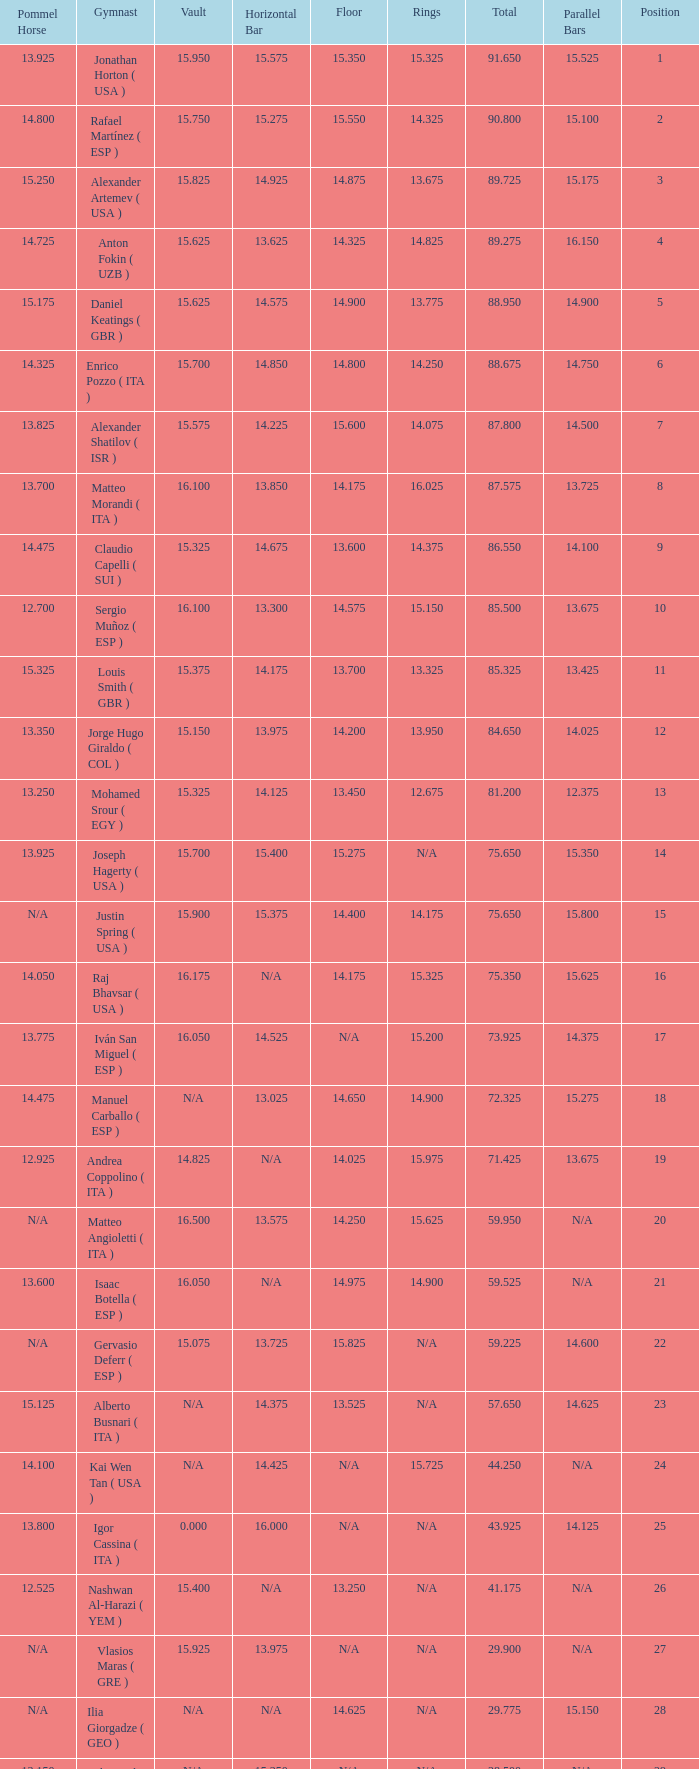Parse the table in full. {'header': ['Pommel Horse', 'Gymnast', 'Vault', 'Horizontal Bar', 'Floor', 'Rings', 'Total', 'Parallel Bars', 'Position'], 'rows': [['13.925', 'Jonathan Horton ( USA )', '15.950', '15.575', '15.350', '15.325', '91.650', '15.525', '1'], ['14.800', 'Rafael Martínez ( ESP )', '15.750', '15.275', '15.550', '14.325', '90.800', '15.100', '2'], ['15.250', 'Alexander Artemev ( USA )', '15.825', '14.925', '14.875', '13.675', '89.725', '15.175', '3'], ['14.725', 'Anton Fokin ( UZB )', '15.625', '13.625', '14.325', '14.825', '89.275', '16.150', '4'], ['15.175', 'Daniel Keatings ( GBR )', '15.625', '14.575', '14.900', '13.775', '88.950', '14.900', '5'], ['14.325', 'Enrico Pozzo ( ITA )', '15.700', '14.850', '14.800', '14.250', '88.675', '14.750', '6'], ['13.825', 'Alexander Shatilov ( ISR )', '15.575', '14.225', '15.600', '14.075', '87.800', '14.500', '7'], ['13.700', 'Matteo Morandi ( ITA )', '16.100', '13.850', '14.175', '16.025', '87.575', '13.725', '8'], ['14.475', 'Claudio Capelli ( SUI )', '15.325', '14.675', '13.600', '14.375', '86.550', '14.100', '9'], ['12.700', 'Sergio Muñoz ( ESP )', '16.100', '13.300', '14.575', '15.150', '85.500', '13.675', '10'], ['15.325', 'Louis Smith ( GBR )', '15.375', '14.175', '13.700', '13.325', '85.325', '13.425', '11'], ['13.350', 'Jorge Hugo Giraldo ( COL )', '15.150', '13.975', '14.200', '13.950', '84.650', '14.025', '12'], ['13.250', 'Mohamed Srour ( EGY )', '15.325', '14.125', '13.450', '12.675', '81.200', '12.375', '13'], ['13.925', 'Joseph Hagerty ( USA )', '15.700', '15.400', '15.275', 'N/A', '75.650', '15.350', '14'], ['N/A', 'Justin Spring ( USA )', '15.900', '15.375', '14.400', '14.175', '75.650', '15.800', '15'], ['14.050', 'Raj Bhavsar ( USA )', '16.175', 'N/A', '14.175', '15.325', '75.350', '15.625', '16'], ['13.775', 'Iván San Miguel ( ESP )', '16.050', '14.525', 'N/A', '15.200', '73.925', '14.375', '17'], ['14.475', 'Manuel Carballo ( ESP )', 'N/A', '13.025', '14.650', '14.900', '72.325', '15.275', '18'], ['12.925', 'Andrea Coppolino ( ITA )', '14.825', 'N/A', '14.025', '15.975', '71.425', '13.675', '19'], ['N/A', 'Matteo Angioletti ( ITA )', '16.500', '13.575', '14.250', '15.625', '59.950', 'N/A', '20'], ['13.600', 'Isaac Botella ( ESP )', '16.050', 'N/A', '14.975', '14.900', '59.525', 'N/A', '21'], ['N/A', 'Gervasio Deferr ( ESP )', '15.075', '13.725', '15.825', 'N/A', '59.225', '14.600', '22'], ['15.125', 'Alberto Busnari ( ITA )', 'N/A', '14.375', '13.525', 'N/A', '57.650', '14.625', '23'], ['14.100', 'Kai Wen Tan ( USA )', 'N/A', '14.425', 'N/A', '15.725', '44.250', 'N/A', '24'], ['13.800', 'Igor Cassina ( ITA )', '0.000', '16.000', 'N/A', 'N/A', '43.925', '14.125', '25'], ['12.525', 'Nashwan Al-Harazi ( YEM )', '15.400', 'N/A', '13.250', 'N/A', '41.175', 'N/A', '26'], ['N/A', 'Vlasios Maras ( GRE )', '15.925', '13.975', 'N/A', 'N/A', '29.900', 'N/A', '27'], ['N/A', 'Ilia Giorgadze ( GEO )', 'N/A', 'N/A', '14.625', 'N/A', '29.775', '15.150', '28'], ['13.150', 'Christoph Schärer ( SUI )', 'N/A', '15.350', 'N/A', 'N/A', '28.500', 'N/A', '29'], ['N/A', 'Leszek Blanik ( POL )', '16.700', 'N/A', 'N/A', 'N/A', '16.700', 'N/A', '30']]} If the parallel bars is 16.150, who is the gymnast? Anton Fokin ( UZB ). 